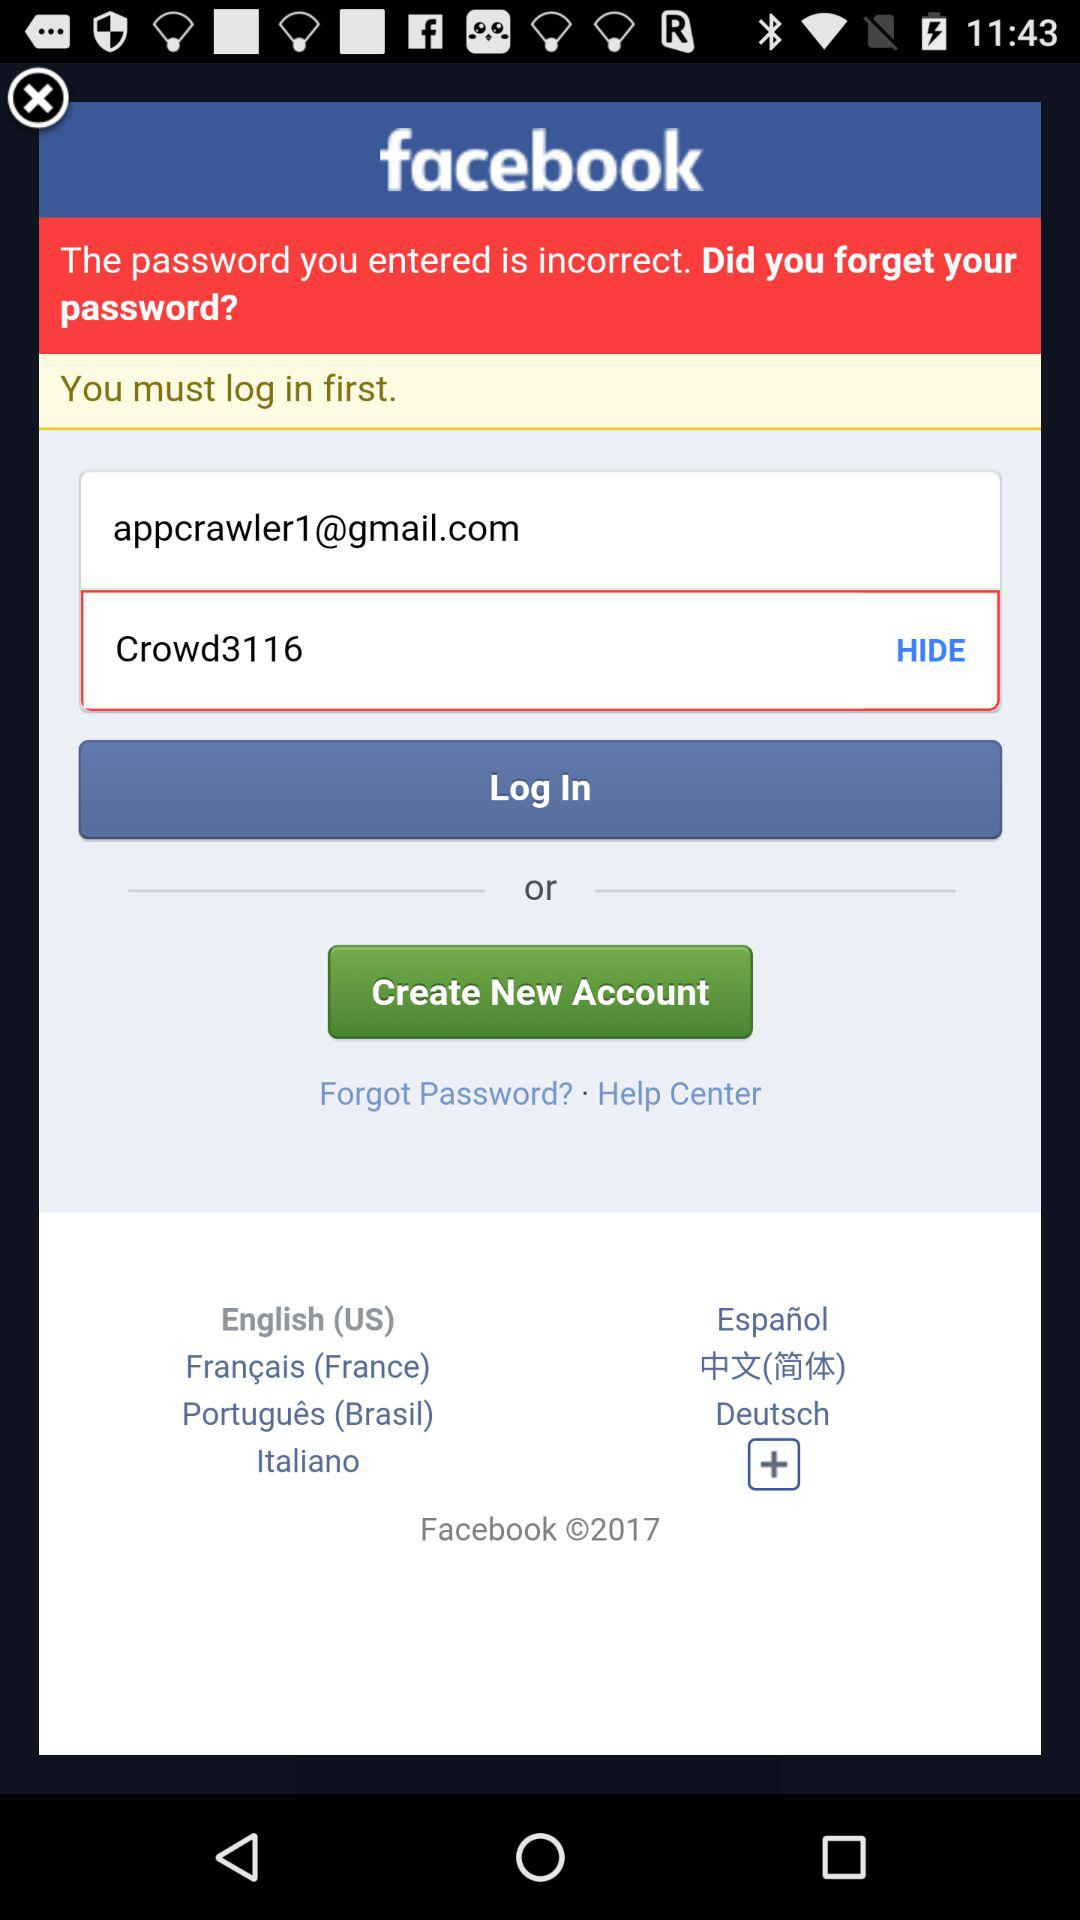What is the email address of the user? The email address of the user is appcrawler1@gmail.com. 